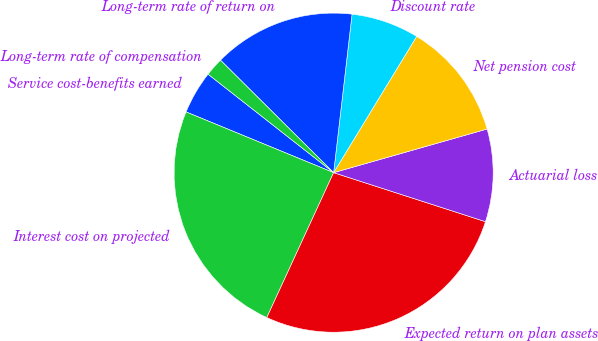Convert chart to OTSL. <chart><loc_0><loc_0><loc_500><loc_500><pie_chart><fcel>Service cost-benefits earned<fcel>Interest cost on projected<fcel>Expected return on plan assets<fcel>Actuarial loss<fcel>Net pension cost<fcel>Discount rate<fcel>Long-term rate of return on<fcel>Long-term rate of compensation<nl><fcel>4.37%<fcel>24.34%<fcel>26.91%<fcel>9.38%<fcel>11.88%<fcel>6.87%<fcel>14.39%<fcel>1.87%<nl></chart> 